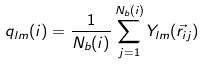Convert formula to latex. <formula><loc_0><loc_0><loc_500><loc_500>q _ { l m } ( i ) = \frac { 1 } { N _ { b } ( i ) } \sum _ { j = 1 } ^ { N _ { b } ( i ) } Y _ { l m } ( \vec { r } _ { i j } )</formula> 